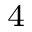<formula> <loc_0><loc_0><loc_500><loc_500>_ { 4 }</formula> 